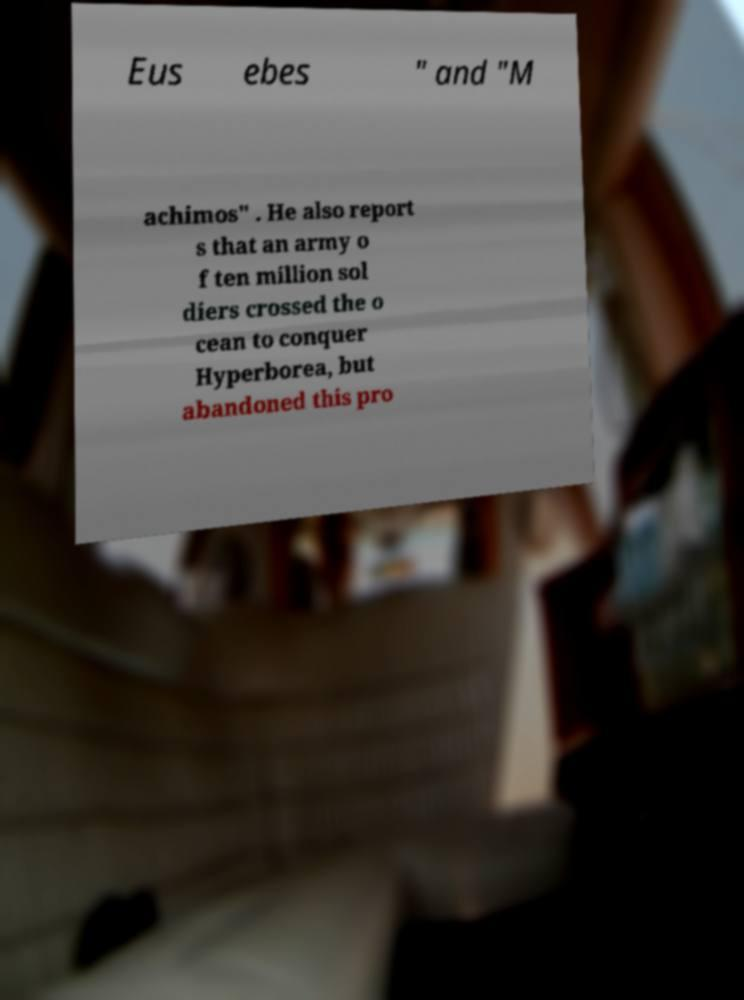For documentation purposes, I need the text within this image transcribed. Could you provide that? Eus ebes " and "M achimos" . He also report s that an army o f ten million sol diers crossed the o cean to conquer Hyperborea, but abandoned this pro 